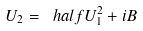Convert formula to latex. <formula><loc_0><loc_0><loc_500><loc_500>U _ { 2 } = \ h a l f U _ { 1 } ^ { 2 } + i B</formula> 